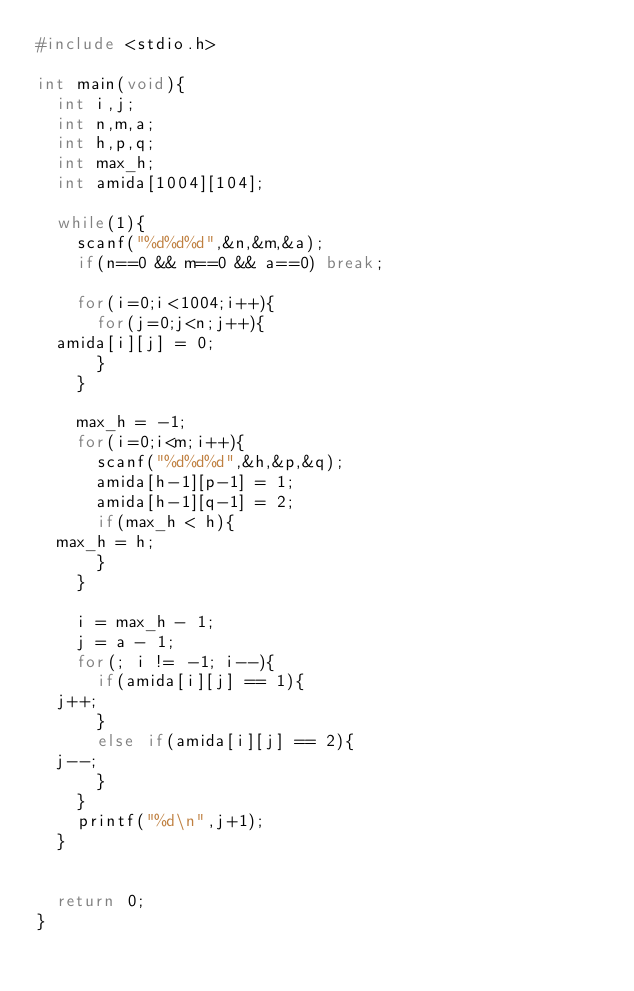Convert code to text. <code><loc_0><loc_0><loc_500><loc_500><_C_>#include <stdio.h>

int main(void){
  int i,j;
  int n,m,a;
  int h,p,q;
  int max_h;
  int amida[1004][104];

  while(1){
    scanf("%d%d%d",&n,&m,&a);
    if(n==0 && m==0 && a==0) break;

    for(i=0;i<1004;i++){
      for(j=0;j<n;j++){
	amida[i][j] = 0;
      }
    }

    max_h = -1;
    for(i=0;i<m;i++){
      scanf("%d%d%d",&h,&p,&q);
      amida[h-1][p-1] = 1;
      amida[h-1][q-1] = 2;
      if(max_h < h){
	max_h = h;
      }
    }

    i = max_h - 1;
    j = a - 1;
    for(; i != -1; i--){
      if(amida[i][j] == 1){
	j++;
      }
      else if(amida[i][j] == 2){
	j--;
      }
    }
    printf("%d\n",j+1);
  }


  return 0;
}</code> 